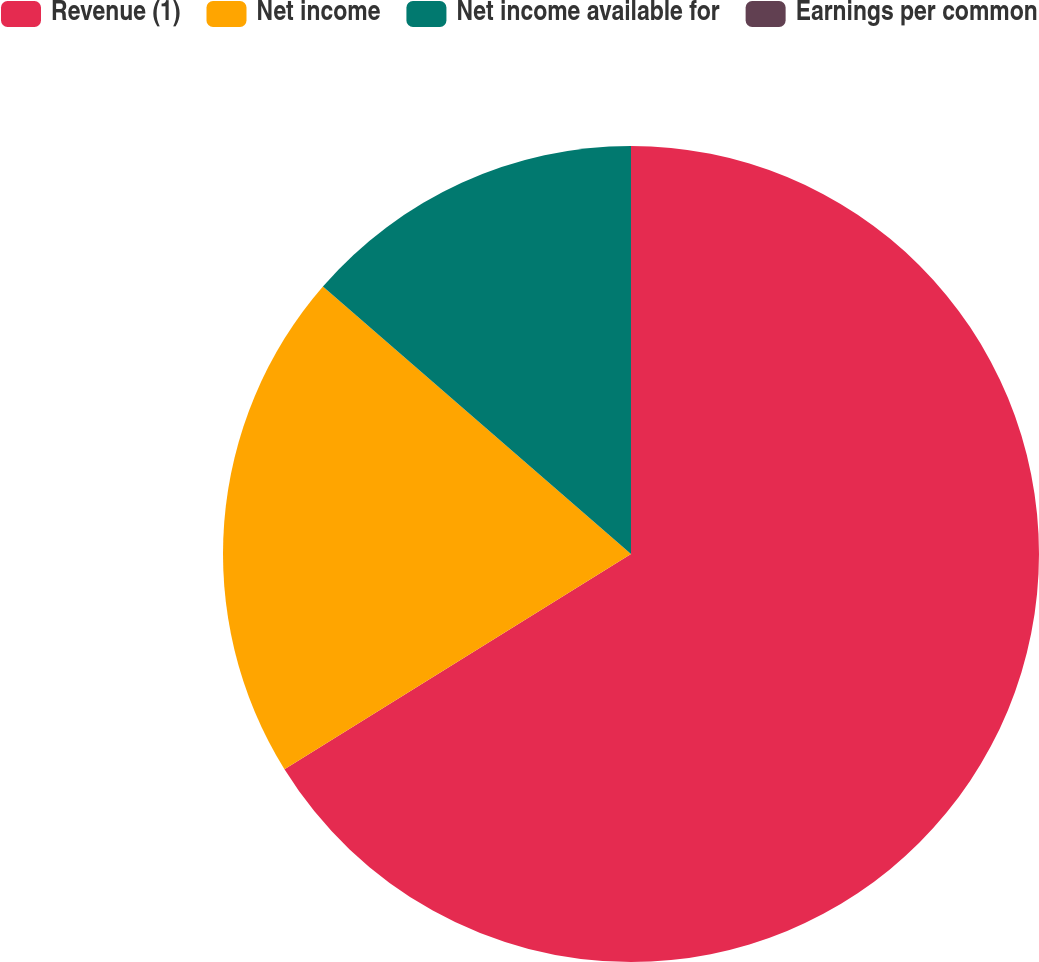<chart> <loc_0><loc_0><loc_500><loc_500><pie_chart><fcel>Revenue (1)<fcel>Net income<fcel>Net income available for<fcel>Earnings per common<nl><fcel>66.15%<fcel>20.23%<fcel>13.62%<fcel>0.0%<nl></chart> 